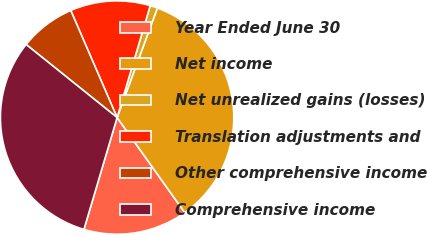<chart> <loc_0><loc_0><loc_500><loc_500><pie_chart><fcel>Year Ended June 30<fcel>Net income<fcel>Net unrealized gains (losses)<fcel>Translation adjustments and<fcel>Other comprehensive income<fcel>Comprehensive income<nl><fcel>14.43%<fcel>34.55%<fcel>1.03%<fcel>11.08%<fcel>7.73%<fcel>31.18%<nl></chart> 